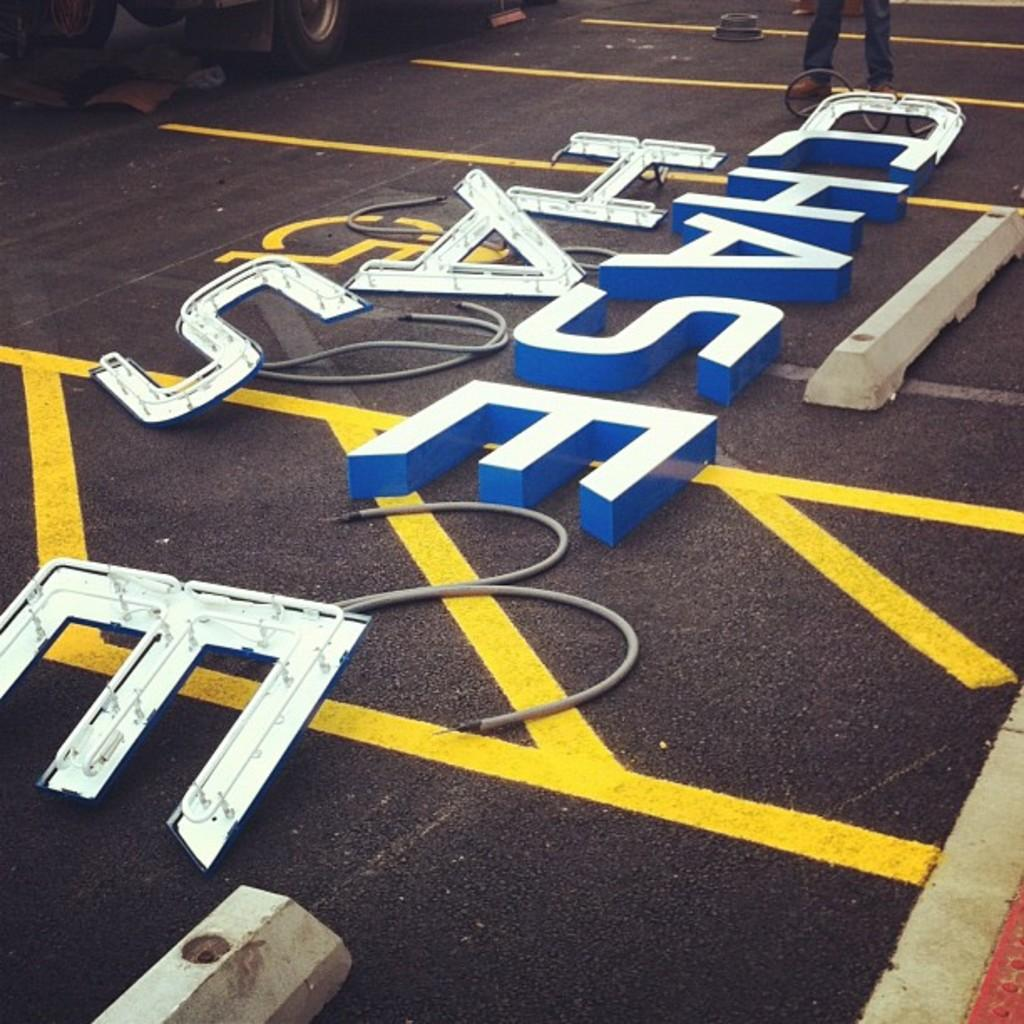What is displayed on the road in the image? There are digital letters on the road. What can be seen in the background of the image? There is a vehicle and the legs of a person visible in the background of the image. What type of caption is written on the rod in the image? There is no rod or caption present in the image. 